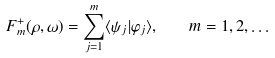Convert formula to latex. <formula><loc_0><loc_0><loc_500><loc_500>F ^ { + } _ { m } ( \rho , \omega ) = \sum _ { j = 1 } ^ { m } \langle \psi _ { j } | \varphi _ { j } \rangle , \quad m = 1 , 2 , \dots</formula> 